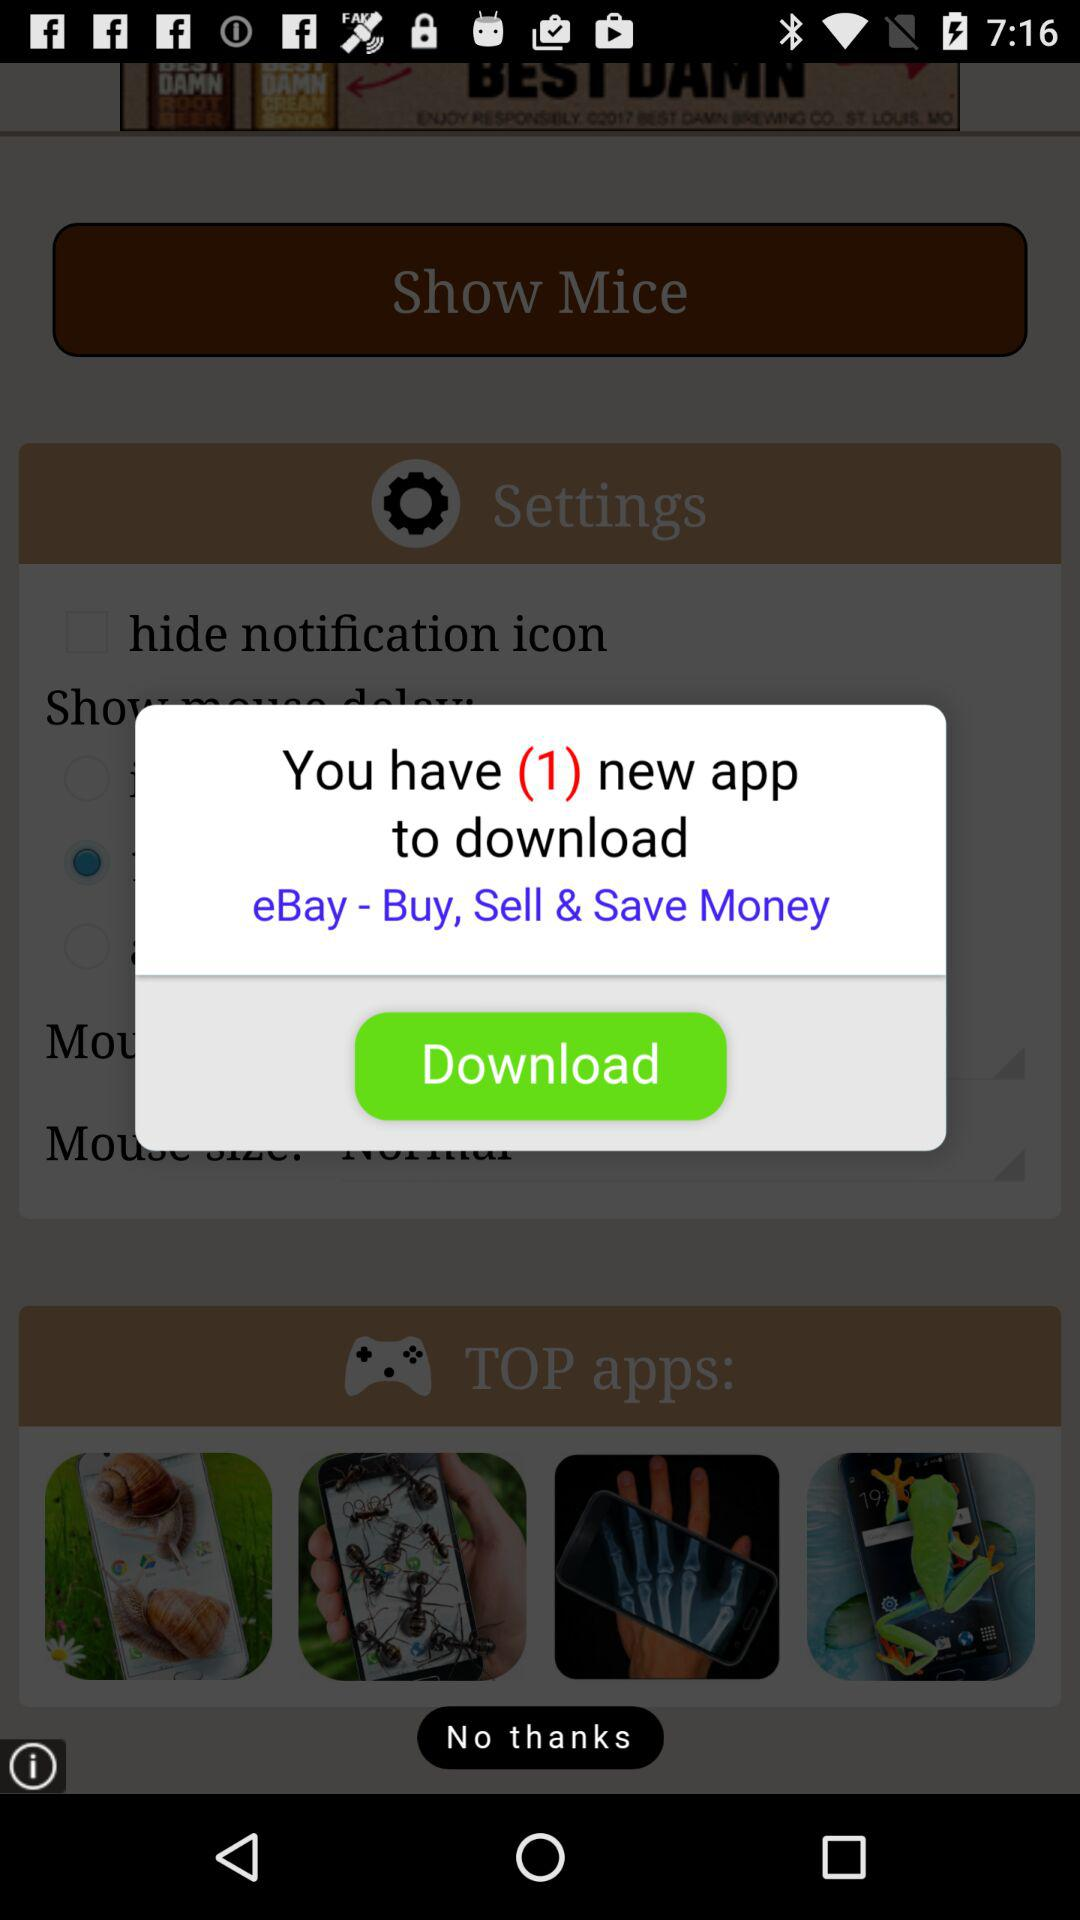How many new apps to download? There is only 1 new app to download. 